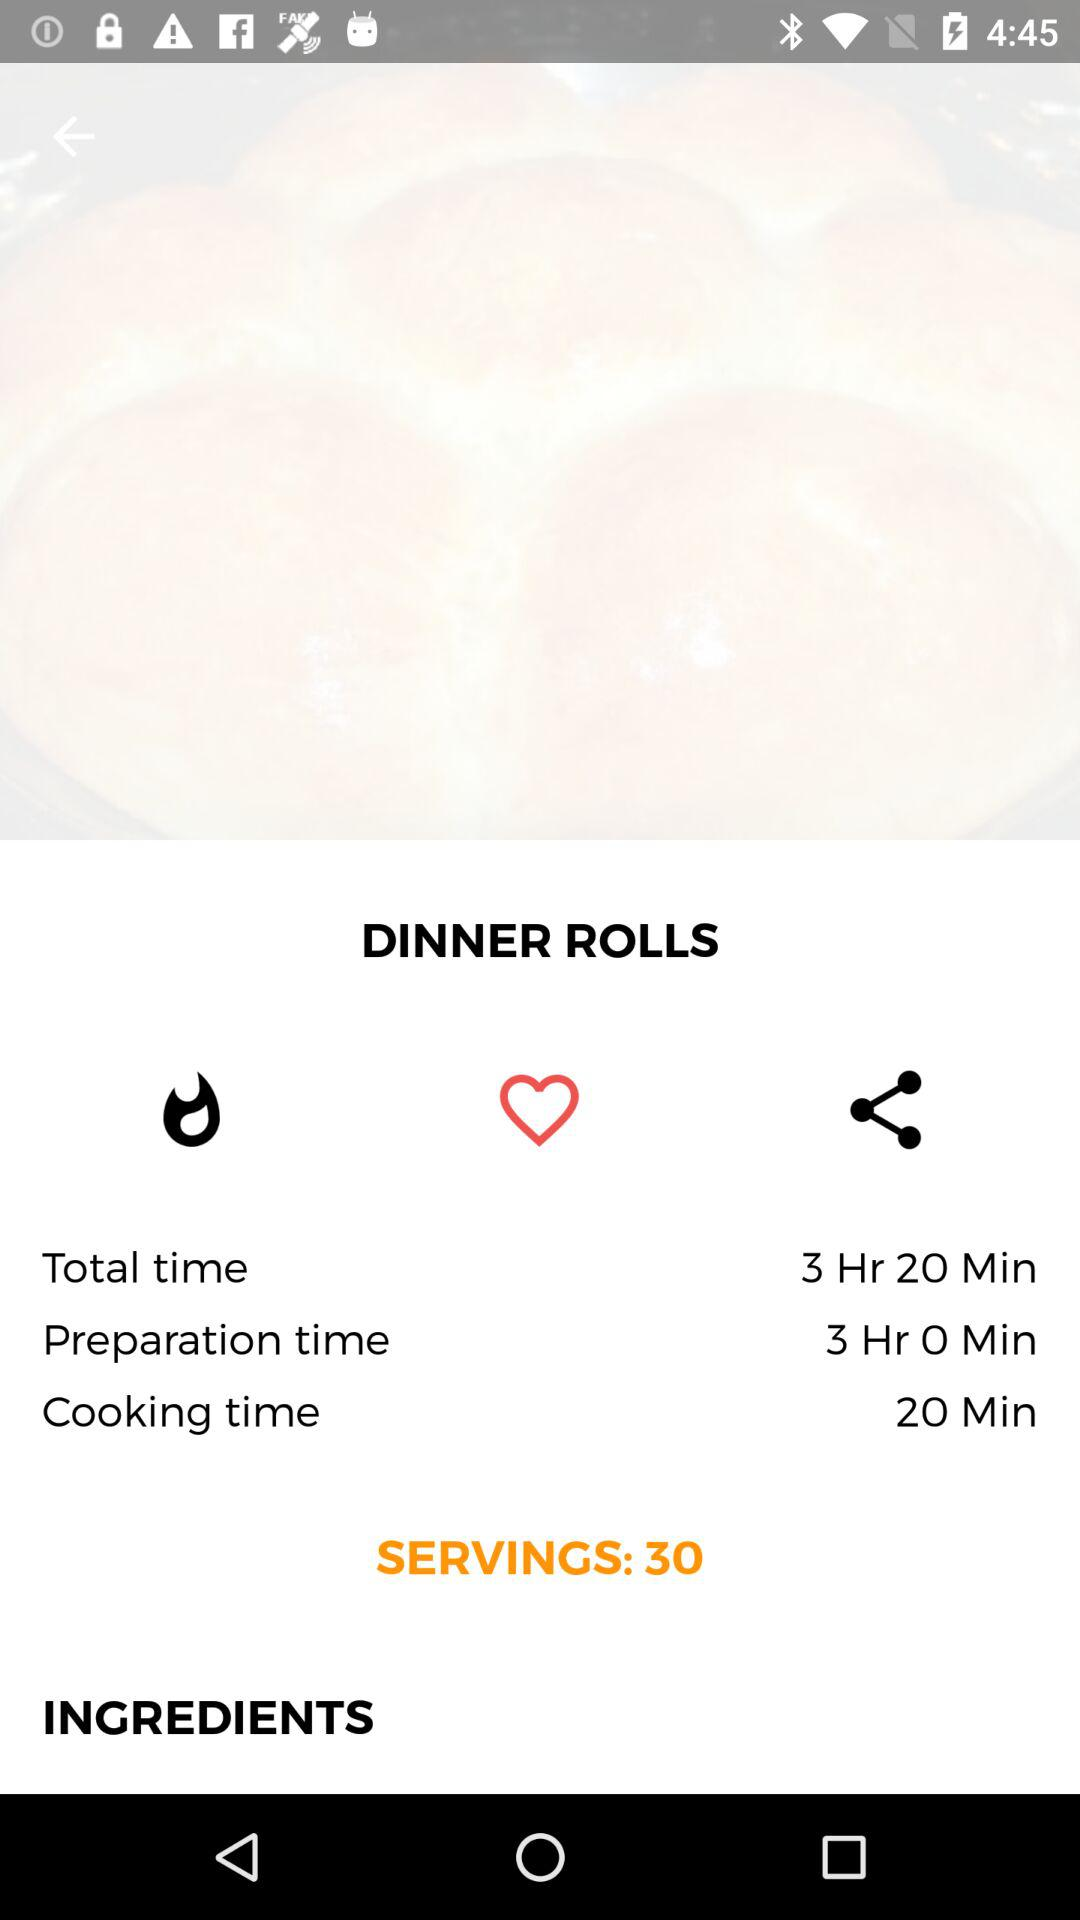What is the preparation time for dinner rolls? The preparation time for dinner rolls is 3 hours. 